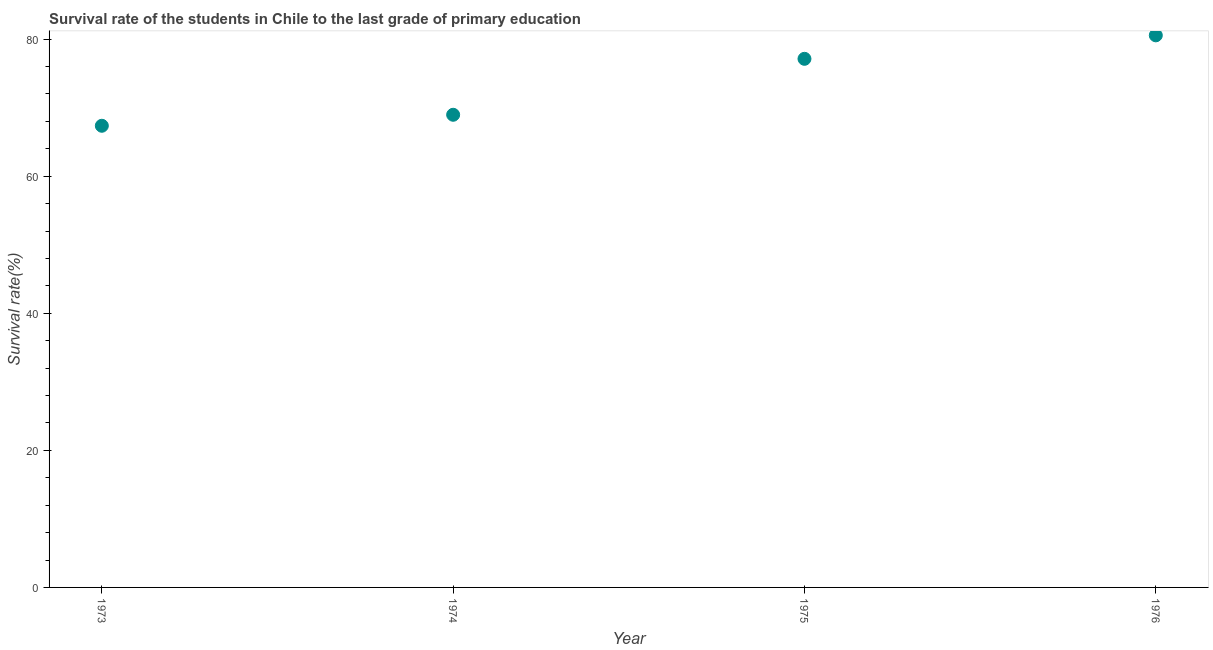What is the survival rate in primary education in 1975?
Provide a succinct answer. 77.13. Across all years, what is the maximum survival rate in primary education?
Offer a terse response. 80.55. Across all years, what is the minimum survival rate in primary education?
Provide a short and direct response. 67.36. In which year was the survival rate in primary education maximum?
Your response must be concise. 1976. What is the sum of the survival rate in primary education?
Keep it short and to the point. 294. What is the difference between the survival rate in primary education in 1973 and 1974?
Give a very brief answer. -1.6. What is the average survival rate in primary education per year?
Provide a succinct answer. 73.5. What is the median survival rate in primary education?
Ensure brevity in your answer.  73.05. In how many years, is the survival rate in primary education greater than 32 %?
Keep it short and to the point. 4. What is the ratio of the survival rate in primary education in 1974 to that in 1975?
Offer a very short reply. 0.89. Is the survival rate in primary education in 1974 less than that in 1976?
Make the answer very short. Yes. What is the difference between the highest and the second highest survival rate in primary education?
Keep it short and to the point. 3.43. What is the difference between the highest and the lowest survival rate in primary education?
Ensure brevity in your answer.  13.19. Does the survival rate in primary education monotonically increase over the years?
Your answer should be very brief. Yes. What is the difference between two consecutive major ticks on the Y-axis?
Your response must be concise. 20. Are the values on the major ticks of Y-axis written in scientific E-notation?
Give a very brief answer. No. Does the graph contain any zero values?
Your response must be concise. No. Does the graph contain grids?
Offer a terse response. No. What is the title of the graph?
Offer a very short reply. Survival rate of the students in Chile to the last grade of primary education. What is the label or title of the X-axis?
Offer a very short reply. Year. What is the label or title of the Y-axis?
Give a very brief answer. Survival rate(%). What is the Survival rate(%) in 1973?
Provide a short and direct response. 67.36. What is the Survival rate(%) in 1974?
Your answer should be very brief. 68.96. What is the Survival rate(%) in 1975?
Your answer should be compact. 77.13. What is the Survival rate(%) in 1976?
Keep it short and to the point. 80.55. What is the difference between the Survival rate(%) in 1973 and 1974?
Your answer should be very brief. -1.6. What is the difference between the Survival rate(%) in 1973 and 1975?
Offer a very short reply. -9.77. What is the difference between the Survival rate(%) in 1973 and 1976?
Give a very brief answer. -13.19. What is the difference between the Survival rate(%) in 1974 and 1975?
Give a very brief answer. -8.16. What is the difference between the Survival rate(%) in 1974 and 1976?
Provide a short and direct response. -11.59. What is the difference between the Survival rate(%) in 1975 and 1976?
Your answer should be compact. -3.43. What is the ratio of the Survival rate(%) in 1973 to that in 1975?
Offer a very short reply. 0.87. What is the ratio of the Survival rate(%) in 1973 to that in 1976?
Your answer should be compact. 0.84. What is the ratio of the Survival rate(%) in 1974 to that in 1975?
Provide a succinct answer. 0.89. What is the ratio of the Survival rate(%) in 1974 to that in 1976?
Ensure brevity in your answer.  0.86. What is the ratio of the Survival rate(%) in 1975 to that in 1976?
Provide a short and direct response. 0.96. 